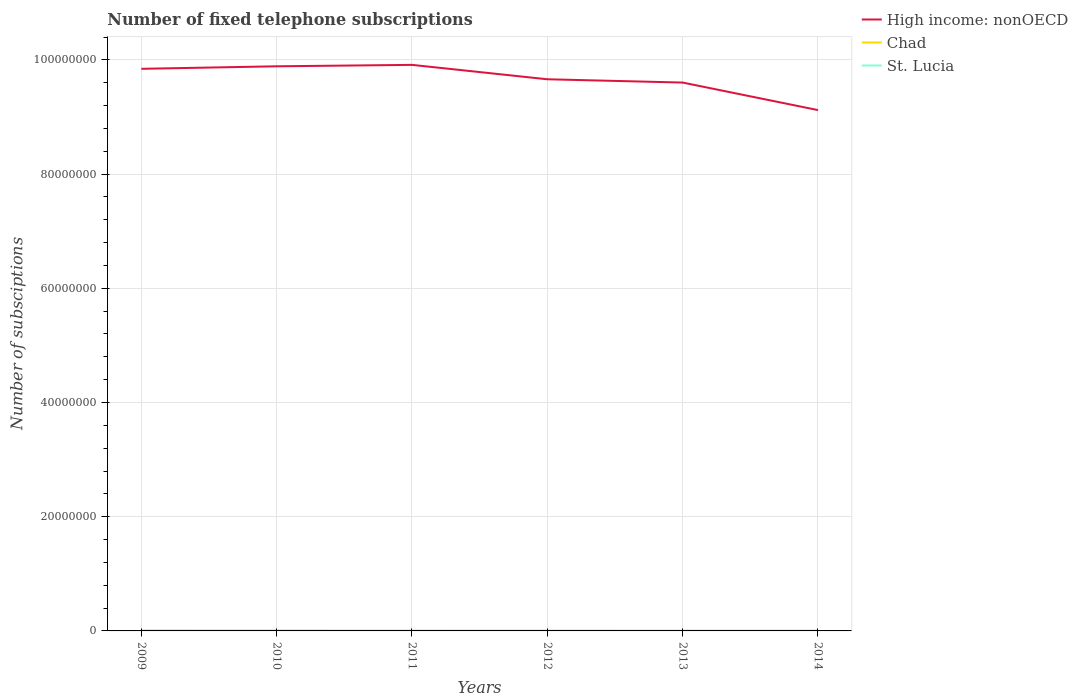How many different coloured lines are there?
Your answer should be compact. 3. Across all years, what is the maximum number of fixed telephone subscriptions in St. Lucia?
Ensure brevity in your answer.  3.28e+04. In which year was the number of fixed telephone subscriptions in St. Lucia maximum?
Provide a succinct answer. 2014. What is the total number of fixed telephone subscriptions in St. Lucia in the graph?
Keep it short and to the point. 3072. What is the difference between the highest and the second highest number of fixed telephone subscriptions in St. Lucia?
Keep it short and to the point. 5729. What is the difference between the highest and the lowest number of fixed telephone subscriptions in Chad?
Your response must be concise. 2. Is the number of fixed telephone subscriptions in Chad strictly greater than the number of fixed telephone subscriptions in High income: nonOECD over the years?
Ensure brevity in your answer.  Yes. How many lines are there?
Provide a short and direct response. 3. Are the values on the major ticks of Y-axis written in scientific E-notation?
Provide a succinct answer. No. Does the graph contain any zero values?
Provide a succinct answer. No. What is the title of the graph?
Make the answer very short. Number of fixed telephone subscriptions. What is the label or title of the Y-axis?
Your response must be concise. Number of subsciptions. What is the Number of subsciptions of High income: nonOECD in 2009?
Your answer should be compact. 9.84e+07. What is the Number of subsciptions in Chad in 2009?
Your response must be concise. 5.83e+04. What is the Number of subsciptions of St. Lucia in 2009?
Keep it short and to the point. 3.86e+04. What is the Number of subsciptions in High income: nonOECD in 2010?
Provide a short and direct response. 9.89e+07. What is the Number of subsciptions of Chad in 2010?
Ensure brevity in your answer.  5.12e+04. What is the Number of subsciptions of St. Lucia in 2010?
Offer a terse response. 3.74e+04. What is the Number of subsciptions of High income: nonOECD in 2011?
Offer a very short reply. 9.91e+07. What is the Number of subsciptions of Chad in 2011?
Your answer should be compact. 3.18e+04. What is the Number of subsciptions in St. Lucia in 2011?
Provide a short and direct response. 3.59e+04. What is the Number of subsciptions in High income: nonOECD in 2012?
Provide a short and direct response. 9.66e+07. What is the Number of subsciptions of Chad in 2012?
Your response must be concise. 2.79e+04. What is the Number of subsciptions of St. Lucia in 2012?
Make the answer very short. 3.68e+04. What is the Number of subsciptions of High income: nonOECD in 2013?
Make the answer very short. 9.60e+07. What is the Number of subsciptions in Chad in 2013?
Your answer should be very brief. 3.13e+04. What is the Number of subsciptions in St. Lucia in 2013?
Provide a succinct answer. 3.35e+04. What is the Number of subsciptions of High income: nonOECD in 2014?
Offer a very short reply. 9.12e+07. What is the Number of subsciptions in Chad in 2014?
Make the answer very short. 2.36e+04. What is the Number of subsciptions in St. Lucia in 2014?
Offer a very short reply. 3.28e+04. Across all years, what is the maximum Number of subsciptions of High income: nonOECD?
Keep it short and to the point. 9.91e+07. Across all years, what is the maximum Number of subsciptions of Chad?
Offer a very short reply. 5.83e+04. Across all years, what is the maximum Number of subsciptions of St. Lucia?
Ensure brevity in your answer.  3.86e+04. Across all years, what is the minimum Number of subsciptions in High income: nonOECD?
Keep it short and to the point. 9.12e+07. Across all years, what is the minimum Number of subsciptions in Chad?
Keep it short and to the point. 2.36e+04. Across all years, what is the minimum Number of subsciptions in St. Lucia?
Keep it short and to the point. 3.28e+04. What is the total Number of subsciptions in High income: nonOECD in the graph?
Keep it short and to the point. 5.80e+08. What is the total Number of subsciptions in Chad in the graph?
Offer a terse response. 2.24e+05. What is the total Number of subsciptions in St. Lucia in the graph?
Provide a succinct answer. 2.15e+05. What is the difference between the Number of subsciptions of High income: nonOECD in 2009 and that in 2010?
Provide a short and direct response. -4.41e+05. What is the difference between the Number of subsciptions in Chad in 2009 and that in 2010?
Your answer should be very brief. 7040. What is the difference between the Number of subsciptions of St. Lucia in 2009 and that in 2010?
Your answer should be compact. 1111. What is the difference between the Number of subsciptions in High income: nonOECD in 2009 and that in 2011?
Provide a succinct answer. -6.91e+05. What is the difference between the Number of subsciptions in Chad in 2009 and that in 2011?
Keep it short and to the point. 2.64e+04. What is the difference between the Number of subsciptions in St. Lucia in 2009 and that in 2011?
Offer a terse response. 2657. What is the difference between the Number of subsciptions of High income: nonOECD in 2009 and that in 2012?
Keep it short and to the point. 1.83e+06. What is the difference between the Number of subsciptions of Chad in 2009 and that in 2012?
Your response must be concise. 3.03e+04. What is the difference between the Number of subsciptions of St. Lucia in 2009 and that in 2012?
Your answer should be very brief. 1719. What is the difference between the Number of subsciptions of High income: nonOECD in 2009 and that in 2013?
Offer a very short reply. 2.41e+06. What is the difference between the Number of subsciptions in Chad in 2009 and that in 2013?
Your answer should be compact. 2.69e+04. What is the difference between the Number of subsciptions in St. Lucia in 2009 and that in 2013?
Ensure brevity in your answer.  5061. What is the difference between the Number of subsciptions in High income: nonOECD in 2009 and that in 2014?
Keep it short and to the point. 7.23e+06. What is the difference between the Number of subsciptions of Chad in 2009 and that in 2014?
Make the answer very short. 3.47e+04. What is the difference between the Number of subsciptions in St. Lucia in 2009 and that in 2014?
Your answer should be compact. 5729. What is the difference between the Number of subsciptions in High income: nonOECD in 2010 and that in 2011?
Offer a terse response. -2.50e+05. What is the difference between the Number of subsciptions of Chad in 2010 and that in 2011?
Your answer should be very brief. 1.94e+04. What is the difference between the Number of subsciptions in St. Lucia in 2010 and that in 2011?
Keep it short and to the point. 1546. What is the difference between the Number of subsciptions in High income: nonOECD in 2010 and that in 2012?
Your answer should be compact. 2.27e+06. What is the difference between the Number of subsciptions in Chad in 2010 and that in 2012?
Give a very brief answer. 2.33e+04. What is the difference between the Number of subsciptions in St. Lucia in 2010 and that in 2012?
Your answer should be compact. 608. What is the difference between the Number of subsciptions of High income: nonOECD in 2010 and that in 2013?
Provide a succinct answer. 2.85e+06. What is the difference between the Number of subsciptions of Chad in 2010 and that in 2013?
Keep it short and to the point. 1.99e+04. What is the difference between the Number of subsciptions in St. Lucia in 2010 and that in 2013?
Your response must be concise. 3950. What is the difference between the Number of subsciptions in High income: nonOECD in 2010 and that in 2014?
Offer a terse response. 7.67e+06. What is the difference between the Number of subsciptions in Chad in 2010 and that in 2014?
Make the answer very short. 2.76e+04. What is the difference between the Number of subsciptions of St. Lucia in 2010 and that in 2014?
Keep it short and to the point. 4618. What is the difference between the Number of subsciptions in High income: nonOECD in 2011 and that in 2012?
Your answer should be very brief. 2.52e+06. What is the difference between the Number of subsciptions of Chad in 2011 and that in 2012?
Make the answer very short. 3902. What is the difference between the Number of subsciptions in St. Lucia in 2011 and that in 2012?
Provide a succinct answer. -938. What is the difference between the Number of subsciptions of High income: nonOECD in 2011 and that in 2013?
Give a very brief answer. 3.10e+06. What is the difference between the Number of subsciptions of Chad in 2011 and that in 2013?
Provide a short and direct response. 516. What is the difference between the Number of subsciptions in St. Lucia in 2011 and that in 2013?
Provide a succinct answer. 2404. What is the difference between the Number of subsciptions in High income: nonOECD in 2011 and that in 2014?
Your answer should be very brief. 7.92e+06. What is the difference between the Number of subsciptions of Chad in 2011 and that in 2014?
Offer a very short reply. 8259. What is the difference between the Number of subsciptions in St. Lucia in 2011 and that in 2014?
Provide a short and direct response. 3072. What is the difference between the Number of subsciptions in High income: nonOECD in 2012 and that in 2013?
Your response must be concise. 5.76e+05. What is the difference between the Number of subsciptions in Chad in 2012 and that in 2013?
Offer a terse response. -3386. What is the difference between the Number of subsciptions of St. Lucia in 2012 and that in 2013?
Provide a short and direct response. 3342. What is the difference between the Number of subsciptions in High income: nonOECD in 2012 and that in 2014?
Offer a very short reply. 5.40e+06. What is the difference between the Number of subsciptions in Chad in 2012 and that in 2014?
Your response must be concise. 4357. What is the difference between the Number of subsciptions in St. Lucia in 2012 and that in 2014?
Your answer should be very brief. 4010. What is the difference between the Number of subsciptions in High income: nonOECD in 2013 and that in 2014?
Provide a short and direct response. 4.82e+06. What is the difference between the Number of subsciptions of Chad in 2013 and that in 2014?
Ensure brevity in your answer.  7743. What is the difference between the Number of subsciptions of St. Lucia in 2013 and that in 2014?
Your answer should be compact. 668. What is the difference between the Number of subsciptions in High income: nonOECD in 2009 and the Number of subsciptions in Chad in 2010?
Offer a very short reply. 9.84e+07. What is the difference between the Number of subsciptions of High income: nonOECD in 2009 and the Number of subsciptions of St. Lucia in 2010?
Your answer should be compact. 9.84e+07. What is the difference between the Number of subsciptions of Chad in 2009 and the Number of subsciptions of St. Lucia in 2010?
Give a very brief answer. 2.08e+04. What is the difference between the Number of subsciptions of High income: nonOECD in 2009 and the Number of subsciptions of Chad in 2011?
Offer a very short reply. 9.84e+07. What is the difference between the Number of subsciptions of High income: nonOECD in 2009 and the Number of subsciptions of St. Lucia in 2011?
Offer a very short reply. 9.84e+07. What is the difference between the Number of subsciptions of Chad in 2009 and the Number of subsciptions of St. Lucia in 2011?
Your answer should be compact. 2.24e+04. What is the difference between the Number of subsciptions in High income: nonOECD in 2009 and the Number of subsciptions in Chad in 2012?
Provide a short and direct response. 9.84e+07. What is the difference between the Number of subsciptions of High income: nonOECD in 2009 and the Number of subsciptions of St. Lucia in 2012?
Offer a very short reply. 9.84e+07. What is the difference between the Number of subsciptions in Chad in 2009 and the Number of subsciptions in St. Lucia in 2012?
Offer a terse response. 2.14e+04. What is the difference between the Number of subsciptions of High income: nonOECD in 2009 and the Number of subsciptions of Chad in 2013?
Ensure brevity in your answer.  9.84e+07. What is the difference between the Number of subsciptions of High income: nonOECD in 2009 and the Number of subsciptions of St. Lucia in 2013?
Your response must be concise. 9.84e+07. What is the difference between the Number of subsciptions in Chad in 2009 and the Number of subsciptions in St. Lucia in 2013?
Ensure brevity in your answer.  2.48e+04. What is the difference between the Number of subsciptions of High income: nonOECD in 2009 and the Number of subsciptions of Chad in 2014?
Make the answer very short. 9.84e+07. What is the difference between the Number of subsciptions in High income: nonOECD in 2009 and the Number of subsciptions in St. Lucia in 2014?
Keep it short and to the point. 9.84e+07. What is the difference between the Number of subsciptions of Chad in 2009 and the Number of subsciptions of St. Lucia in 2014?
Give a very brief answer. 2.54e+04. What is the difference between the Number of subsciptions of High income: nonOECD in 2010 and the Number of subsciptions of Chad in 2011?
Your answer should be very brief. 9.88e+07. What is the difference between the Number of subsciptions of High income: nonOECD in 2010 and the Number of subsciptions of St. Lucia in 2011?
Your answer should be very brief. 9.88e+07. What is the difference between the Number of subsciptions of Chad in 2010 and the Number of subsciptions of St. Lucia in 2011?
Offer a very short reply. 1.53e+04. What is the difference between the Number of subsciptions in High income: nonOECD in 2010 and the Number of subsciptions in Chad in 2012?
Provide a succinct answer. 9.89e+07. What is the difference between the Number of subsciptions of High income: nonOECD in 2010 and the Number of subsciptions of St. Lucia in 2012?
Keep it short and to the point. 9.88e+07. What is the difference between the Number of subsciptions of Chad in 2010 and the Number of subsciptions of St. Lucia in 2012?
Give a very brief answer. 1.44e+04. What is the difference between the Number of subsciptions of High income: nonOECD in 2010 and the Number of subsciptions of Chad in 2013?
Offer a terse response. 9.88e+07. What is the difference between the Number of subsciptions of High income: nonOECD in 2010 and the Number of subsciptions of St. Lucia in 2013?
Provide a short and direct response. 9.88e+07. What is the difference between the Number of subsciptions of Chad in 2010 and the Number of subsciptions of St. Lucia in 2013?
Provide a short and direct response. 1.77e+04. What is the difference between the Number of subsciptions in High income: nonOECD in 2010 and the Number of subsciptions in Chad in 2014?
Offer a terse response. 9.89e+07. What is the difference between the Number of subsciptions of High income: nonOECD in 2010 and the Number of subsciptions of St. Lucia in 2014?
Your answer should be compact. 9.88e+07. What is the difference between the Number of subsciptions of Chad in 2010 and the Number of subsciptions of St. Lucia in 2014?
Provide a short and direct response. 1.84e+04. What is the difference between the Number of subsciptions of High income: nonOECD in 2011 and the Number of subsciptions of Chad in 2012?
Your answer should be compact. 9.91e+07. What is the difference between the Number of subsciptions of High income: nonOECD in 2011 and the Number of subsciptions of St. Lucia in 2012?
Offer a terse response. 9.91e+07. What is the difference between the Number of subsciptions of Chad in 2011 and the Number of subsciptions of St. Lucia in 2012?
Your answer should be compact. -5003. What is the difference between the Number of subsciptions of High income: nonOECD in 2011 and the Number of subsciptions of Chad in 2013?
Provide a short and direct response. 9.91e+07. What is the difference between the Number of subsciptions of High income: nonOECD in 2011 and the Number of subsciptions of St. Lucia in 2013?
Ensure brevity in your answer.  9.91e+07. What is the difference between the Number of subsciptions in Chad in 2011 and the Number of subsciptions in St. Lucia in 2013?
Provide a succinct answer. -1661. What is the difference between the Number of subsciptions of High income: nonOECD in 2011 and the Number of subsciptions of Chad in 2014?
Your answer should be very brief. 9.91e+07. What is the difference between the Number of subsciptions of High income: nonOECD in 2011 and the Number of subsciptions of St. Lucia in 2014?
Your response must be concise. 9.91e+07. What is the difference between the Number of subsciptions in Chad in 2011 and the Number of subsciptions in St. Lucia in 2014?
Offer a very short reply. -993. What is the difference between the Number of subsciptions of High income: nonOECD in 2012 and the Number of subsciptions of Chad in 2013?
Provide a short and direct response. 9.66e+07. What is the difference between the Number of subsciptions in High income: nonOECD in 2012 and the Number of subsciptions in St. Lucia in 2013?
Offer a very short reply. 9.66e+07. What is the difference between the Number of subsciptions of Chad in 2012 and the Number of subsciptions of St. Lucia in 2013?
Give a very brief answer. -5563. What is the difference between the Number of subsciptions of High income: nonOECD in 2012 and the Number of subsciptions of Chad in 2014?
Offer a very short reply. 9.66e+07. What is the difference between the Number of subsciptions in High income: nonOECD in 2012 and the Number of subsciptions in St. Lucia in 2014?
Your response must be concise. 9.66e+07. What is the difference between the Number of subsciptions in Chad in 2012 and the Number of subsciptions in St. Lucia in 2014?
Ensure brevity in your answer.  -4895. What is the difference between the Number of subsciptions in High income: nonOECD in 2013 and the Number of subsciptions in Chad in 2014?
Keep it short and to the point. 9.60e+07. What is the difference between the Number of subsciptions in High income: nonOECD in 2013 and the Number of subsciptions in St. Lucia in 2014?
Offer a very short reply. 9.60e+07. What is the difference between the Number of subsciptions of Chad in 2013 and the Number of subsciptions of St. Lucia in 2014?
Make the answer very short. -1509. What is the average Number of subsciptions in High income: nonOECD per year?
Provide a succinct answer. 9.67e+07. What is the average Number of subsciptions in Chad per year?
Provide a succinct answer. 3.74e+04. What is the average Number of subsciptions in St. Lucia per year?
Your answer should be compact. 3.58e+04. In the year 2009, what is the difference between the Number of subsciptions of High income: nonOECD and Number of subsciptions of Chad?
Offer a very short reply. 9.84e+07. In the year 2009, what is the difference between the Number of subsciptions in High income: nonOECD and Number of subsciptions in St. Lucia?
Ensure brevity in your answer.  9.84e+07. In the year 2009, what is the difference between the Number of subsciptions in Chad and Number of subsciptions in St. Lucia?
Ensure brevity in your answer.  1.97e+04. In the year 2010, what is the difference between the Number of subsciptions of High income: nonOECD and Number of subsciptions of Chad?
Your answer should be very brief. 9.88e+07. In the year 2010, what is the difference between the Number of subsciptions of High income: nonOECD and Number of subsciptions of St. Lucia?
Ensure brevity in your answer.  9.88e+07. In the year 2010, what is the difference between the Number of subsciptions in Chad and Number of subsciptions in St. Lucia?
Provide a short and direct response. 1.38e+04. In the year 2011, what is the difference between the Number of subsciptions of High income: nonOECD and Number of subsciptions of Chad?
Ensure brevity in your answer.  9.91e+07. In the year 2011, what is the difference between the Number of subsciptions of High income: nonOECD and Number of subsciptions of St. Lucia?
Provide a short and direct response. 9.91e+07. In the year 2011, what is the difference between the Number of subsciptions of Chad and Number of subsciptions of St. Lucia?
Your answer should be compact. -4065. In the year 2012, what is the difference between the Number of subsciptions in High income: nonOECD and Number of subsciptions in Chad?
Provide a short and direct response. 9.66e+07. In the year 2012, what is the difference between the Number of subsciptions of High income: nonOECD and Number of subsciptions of St. Lucia?
Your answer should be very brief. 9.66e+07. In the year 2012, what is the difference between the Number of subsciptions of Chad and Number of subsciptions of St. Lucia?
Keep it short and to the point. -8905. In the year 2013, what is the difference between the Number of subsciptions in High income: nonOECD and Number of subsciptions in Chad?
Provide a succinct answer. 9.60e+07. In the year 2013, what is the difference between the Number of subsciptions of High income: nonOECD and Number of subsciptions of St. Lucia?
Offer a very short reply. 9.60e+07. In the year 2013, what is the difference between the Number of subsciptions of Chad and Number of subsciptions of St. Lucia?
Ensure brevity in your answer.  -2177. In the year 2014, what is the difference between the Number of subsciptions in High income: nonOECD and Number of subsciptions in Chad?
Provide a succinct answer. 9.12e+07. In the year 2014, what is the difference between the Number of subsciptions in High income: nonOECD and Number of subsciptions in St. Lucia?
Your answer should be very brief. 9.12e+07. In the year 2014, what is the difference between the Number of subsciptions in Chad and Number of subsciptions in St. Lucia?
Offer a terse response. -9252. What is the ratio of the Number of subsciptions of High income: nonOECD in 2009 to that in 2010?
Offer a very short reply. 1. What is the ratio of the Number of subsciptions in Chad in 2009 to that in 2010?
Your answer should be very brief. 1.14. What is the ratio of the Number of subsciptions of St. Lucia in 2009 to that in 2010?
Your response must be concise. 1.03. What is the ratio of the Number of subsciptions in Chad in 2009 to that in 2011?
Ensure brevity in your answer.  1.83. What is the ratio of the Number of subsciptions of St. Lucia in 2009 to that in 2011?
Your answer should be very brief. 1.07. What is the ratio of the Number of subsciptions of High income: nonOECD in 2009 to that in 2012?
Provide a short and direct response. 1.02. What is the ratio of the Number of subsciptions of Chad in 2009 to that in 2012?
Your answer should be very brief. 2.09. What is the ratio of the Number of subsciptions in St. Lucia in 2009 to that in 2012?
Your response must be concise. 1.05. What is the ratio of the Number of subsciptions of High income: nonOECD in 2009 to that in 2013?
Keep it short and to the point. 1.03. What is the ratio of the Number of subsciptions in Chad in 2009 to that in 2013?
Make the answer very short. 1.86. What is the ratio of the Number of subsciptions in St. Lucia in 2009 to that in 2013?
Your answer should be compact. 1.15. What is the ratio of the Number of subsciptions of High income: nonOECD in 2009 to that in 2014?
Offer a terse response. 1.08. What is the ratio of the Number of subsciptions of Chad in 2009 to that in 2014?
Offer a terse response. 2.47. What is the ratio of the Number of subsciptions of St. Lucia in 2009 to that in 2014?
Provide a short and direct response. 1.17. What is the ratio of the Number of subsciptions in Chad in 2010 to that in 2011?
Keep it short and to the point. 1.61. What is the ratio of the Number of subsciptions of St. Lucia in 2010 to that in 2011?
Provide a short and direct response. 1.04. What is the ratio of the Number of subsciptions of High income: nonOECD in 2010 to that in 2012?
Your answer should be compact. 1.02. What is the ratio of the Number of subsciptions of Chad in 2010 to that in 2012?
Offer a very short reply. 1.83. What is the ratio of the Number of subsciptions in St. Lucia in 2010 to that in 2012?
Offer a very short reply. 1.02. What is the ratio of the Number of subsciptions of High income: nonOECD in 2010 to that in 2013?
Provide a succinct answer. 1.03. What is the ratio of the Number of subsciptions of Chad in 2010 to that in 2013?
Make the answer very short. 1.64. What is the ratio of the Number of subsciptions in St. Lucia in 2010 to that in 2013?
Keep it short and to the point. 1.12. What is the ratio of the Number of subsciptions of High income: nonOECD in 2010 to that in 2014?
Make the answer very short. 1.08. What is the ratio of the Number of subsciptions of Chad in 2010 to that in 2014?
Offer a very short reply. 2.17. What is the ratio of the Number of subsciptions of St. Lucia in 2010 to that in 2014?
Keep it short and to the point. 1.14. What is the ratio of the Number of subsciptions of High income: nonOECD in 2011 to that in 2012?
Keep it short and to the point. 1.03. What is the ratio of the Number of subsciptions of Chad in 2011 to that in 2012?
Your answer should be very brief. 1.14. What is the ratio of the Number of subsciptions in St. Lucia in 2011 to that in 2012?
Offer a terse response. 0.97. What is the ratio of the Number of subsciptions of High income: nonOECD in 2011 to that in 2013?
Your answer should be compact. 1.03. What is the ratio of the Number of subsciptions in Chad in 2011 to that in 2013?
Your answer should be compact. 1.02. What is the ratio of the Number of subsciptions in St. Lucia in 2011 to that in 2013?
Your response must be concise. 1.07. What is the ratio of the Number of subsciptions of High income: nonOECD in 2011 to that in 2014?
Your answer should be compact. 1.09. What is the ratio of the Number of subsciptions of Chad in 2011 to that in 2014?
Your answer should be very brief. 1.35. What is the ratio of the Number of subsciptions in St. Lucia in 2011 to that in 2014?
Make the answer very short. 1.09. What is the ratio of the Number of subsciptions in High income: nonOECD in 2012 to that in 2013?
Make the answer very short. 1.01. What is the ratio of the Number of subsciptions of Chad in 2012 to that in 2013?
Offer a terse response. 0.89. What is the ratio of the Number of subsciptions in St. Lucia in 2012 to that in 2013?
Offer a terse response. 1.1. What is the ratio of the Number of subsciptions of High income: nonOECD in 2012 to that in 2014?
Give a very brief answer. 1.06. What is the ratio of the Number of subsciptions of Chad in 2012 to that in 2014?
Make the answer very short. 1.18. What is the ratio of the Number of subsciptions in St. Lucia in 2012 to that in 2014?
Offer a very short reply. 1.12. What is the ratio of the Number of subsciptions of High income: nonOECD in 2013 to that in 2014?
Your answer should be compact. 1.05. What is the ratio of the Number of subsciptions in Chad in 2013 to that in 2014?
Give a very brief answer. 1.33. What is the ratio of the Number of subsciptions of St. Lucia in 2013 to that in 2014?
Your response must be concise. 1.02. What is the difference between the highest and the second highest Number of subsciptions in High income: nonOECD?
Give a very brief answer. 2.50e+05. What is the difference between the highest and the second highest Number of subsciptions of Chad?
Keep it short and to the point. 7040. What is the difference between the highest and the second highest Number of subsciptions of St. Lucia?
Provide a short and direct response. 1111. What is the difference between the highest and the lowest Number of subsciptions of High income: nonOECD?
Your answer should be very brief. 7.92e+06. What is the difference between the highest and the lowest Number of subsciptions of Chad?
Keep it short and to the point. 3.47e+04. What is the difference between the highest and the lowest Number of subsciptions in St. Lucia?
Make the answer very short. 5729. 